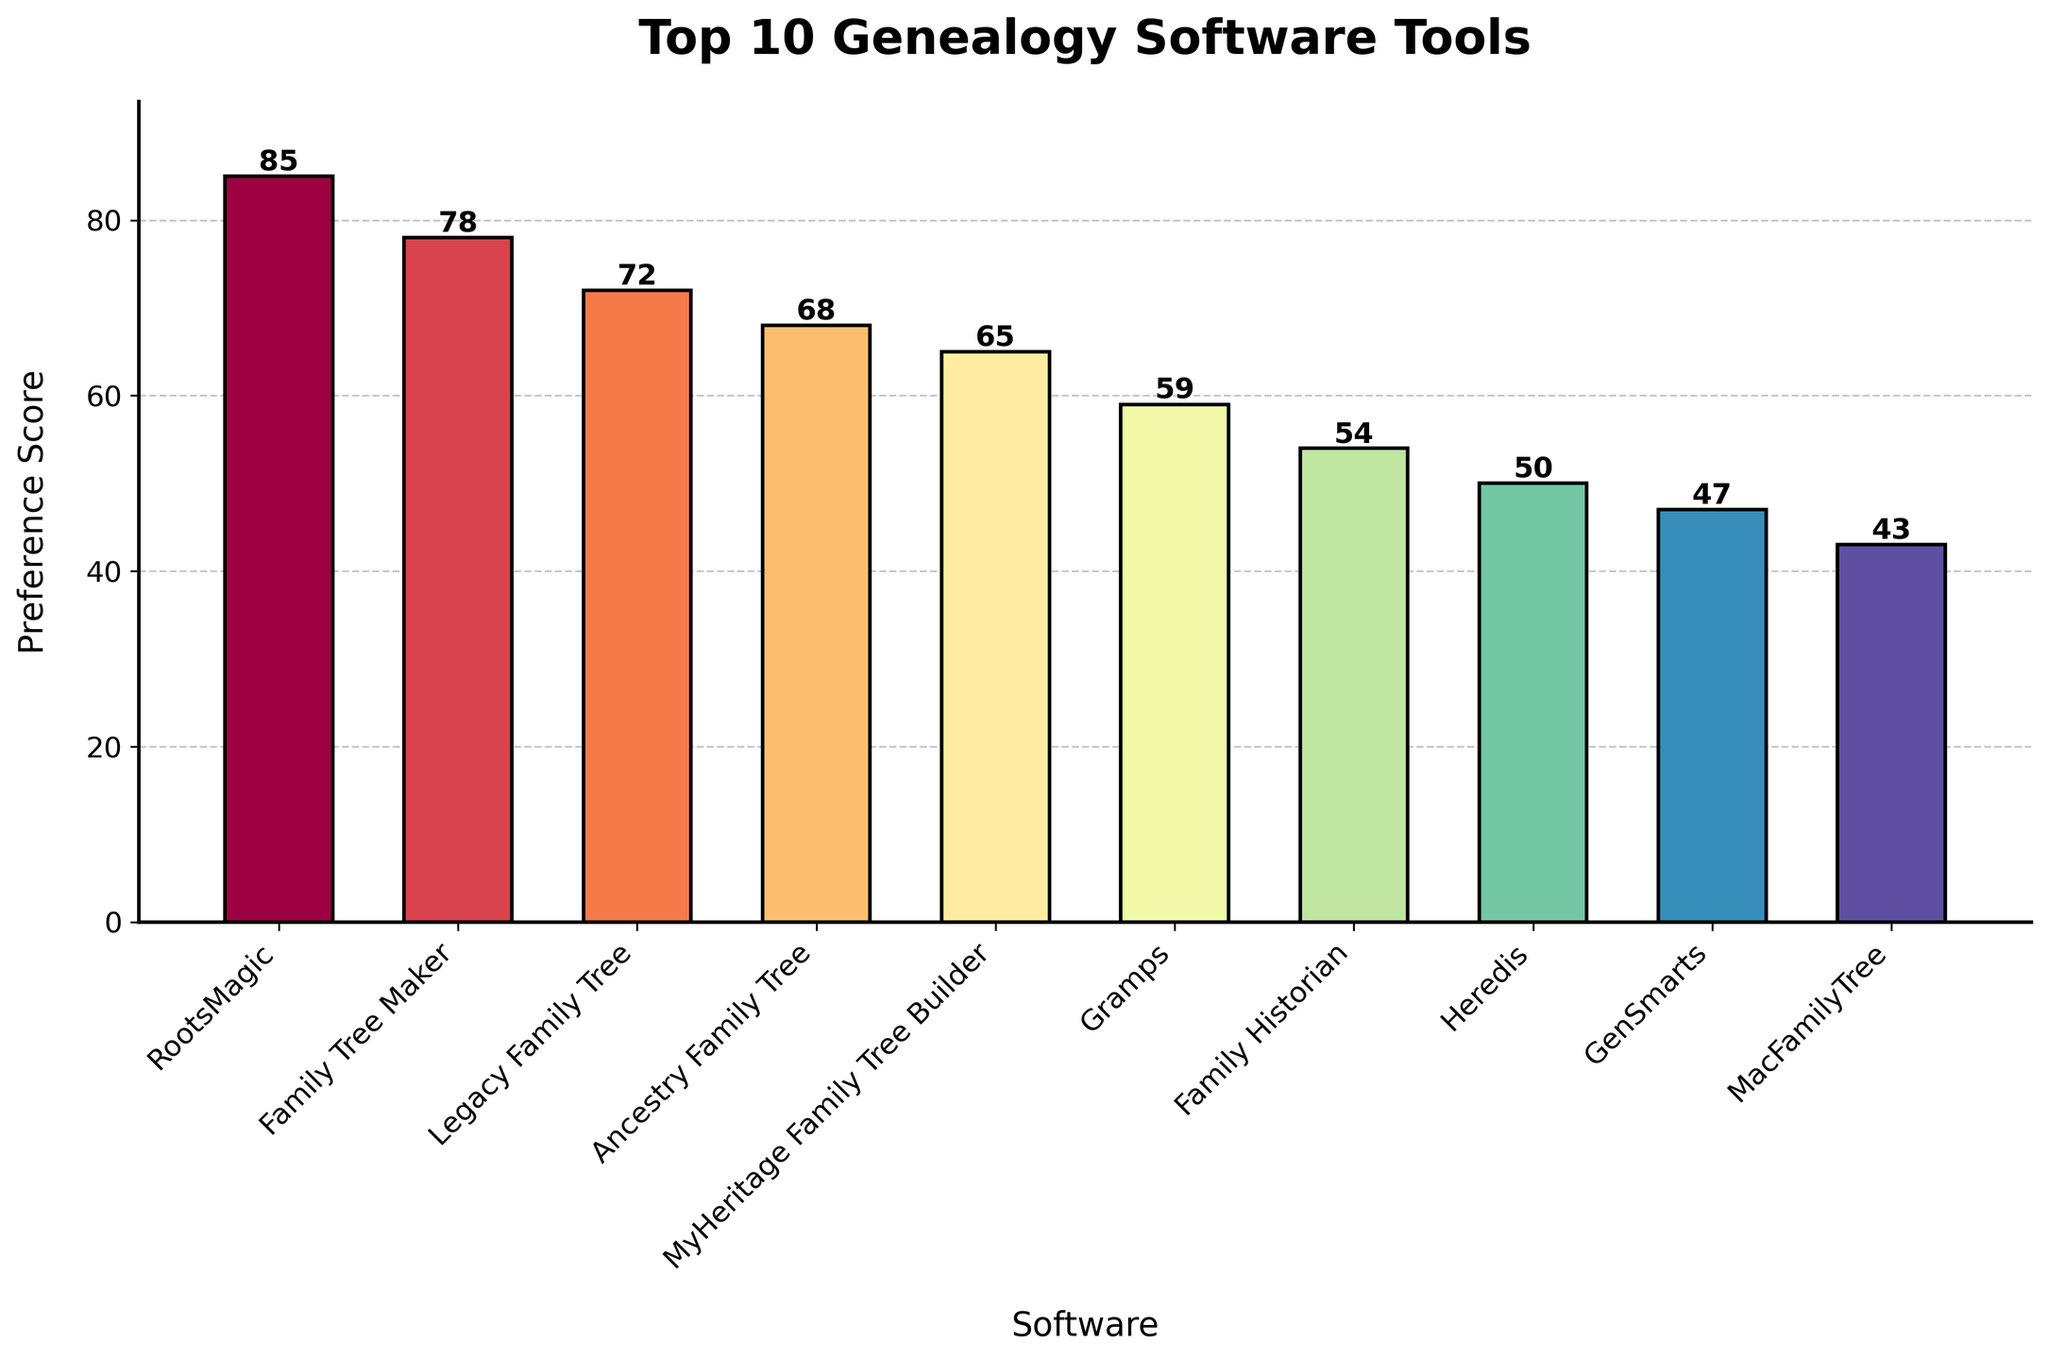Which genealogy software tool has the highest preference score? The bar representing RootsMagic is the tallest in the figure, which indicates it has the highest preference score
Answer: RootsMagic What is the difference in preference score between the top-ranked and the bottom-ranked genealogy software tools? The preference score of RootsMagic (top-ranked) is 85, and the preference score of MacFamilyTree (bottom-ranked) is 43. The difference is 85 - 43 = 42
Answer: 42 Which two software tools have the closest preference scores? The preferences scores of Heredis and GenSmarts are 50 and 47, respectively, which is a difference of only 3. This is the smallest difference between any two consecutive entries on the chart
Answer: Heredis and GenSmarts What is the average preference score of the top 5 genealogy software tools? The top 5 tools are RootsMagic, Family Tree Maker, Legacy Family Tree, Ancestry Family Tree, and MyHeritage Family Tree Builder. Summing up their scores: 85 + 78 + 72 + 68 + 65 = 368. Dividing by 5 gives 368 / 5 = 73.6
Answer: 73.6 Which genealogy software tool ranks fourth in user preference? By looking at the heights of the bars, Ancestry Family Tree ranks fourth with a preference score of 68
Answer: Ancestry Family Tree How many genealogy software tools have a preference score above 60? Counting the bars with heights above 60: RootsMagic, Family Tree Maker, Legacy Family Tree, Ancestry Family Tree, and MyHeritage Family Tree Builder, which are 5 tools in total
Answer: 5 What is the cumulative preference score of all the genealogy software tools shown in the figure? Adding up all the preference scores: 85 + 78 + 72 + 68 + 65 + 59 + 54 + 50 + 47 + 43 = 621
Answer: 621 By how much does Family Historian's preference score fall short of Gramps'? Family Historian's score is 54, and Gramps' score is 59. The difference is 59 - 54 = 5
Answer: 5 Is the preference score of Legacy Family Tree closer to that of Family Tree Maker or MyHeritage Family Tree Builder? Legacy Family Tree's score is 72, Family Tree Maker's is 78, and MyHeritage Family Tree Builder's is 65. The differences are abs(72 - 78) = 6 and abs(72 - 65) = 7. So, it is closer to Family Tree Maker
Answer: Family Tree Maker 